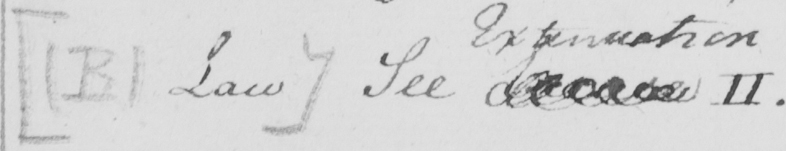Can you tell me what this handwritten text says? [  ( B )  Law ]  See Excuse II 